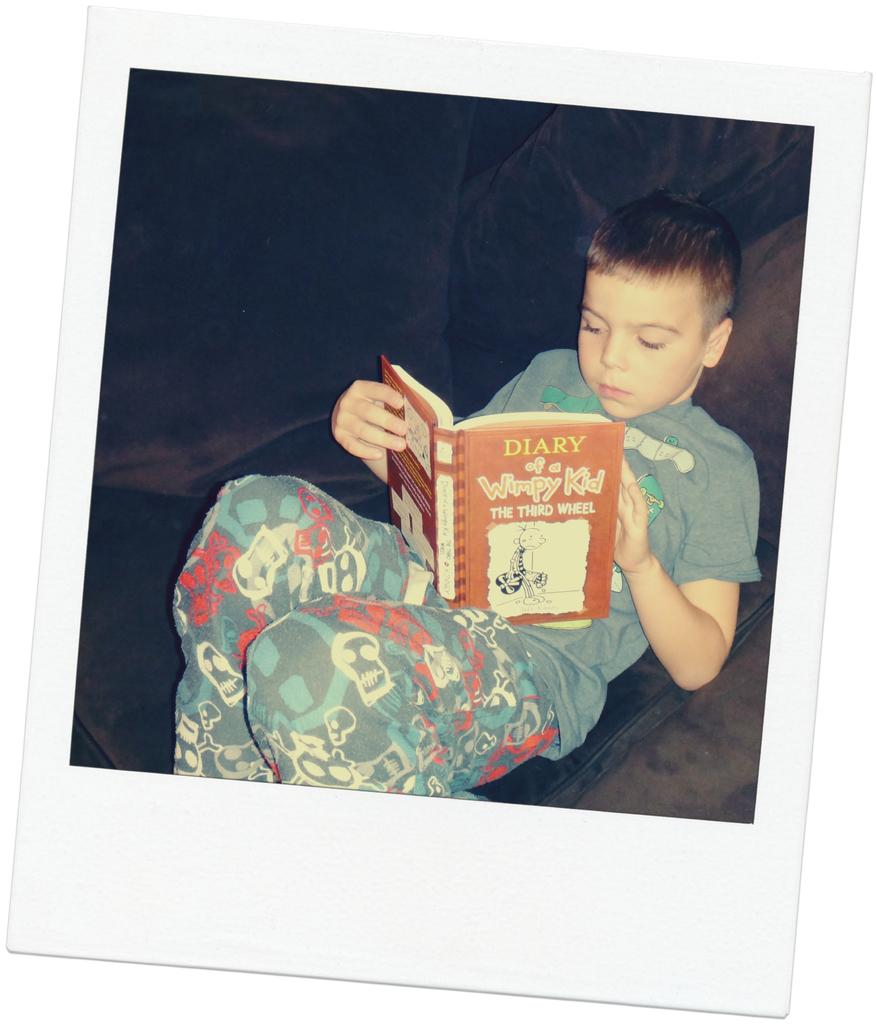What book is the child reading?
Offer a terse response. Diary of a wimpy kid. What wheel is this book about?
Your answer should be compact. Third. 